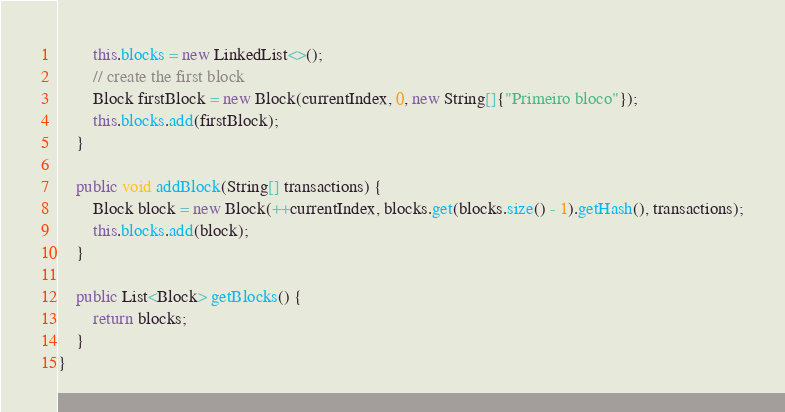<code> <loc_0><loc_0><loc_500><loc_500><_Java_>        this.blocks = new LinkedList<>();
        // create the first block
        Block firstBlock = new Block(currentIndex, 0, new String[]{"Primeiro bloco"});
        this.blocks.add(firstBlock);
    }

    public void addBlock(String[] transactions) {
        Block block = new Block(++currentIndex, blocks.get(blocks.size() - 1).getHash(), transactions);
        this.blocks.add(block);
    }

    public List<Block> getBlocks() {
        return blocks;
    }
}
</code> 